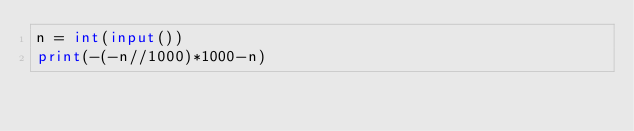Convert code to text. <code><loc_0><loc_0><loc_500><loc_500><_Python_>n = int(input())
print(-(-n//1000)*1000-n)</code> 